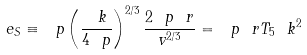<formula> <loc_0><loc_0><loc_500><loc_500>\ e _ { S } \equiv \ p \left ( \frac { \ k } { 4 \ p } \right ) ^ { 2 / 3 } \frac { 2 \ p \ r } { v ^ { 2 / 3 } } = \ p \ r T _ { 5 } \ k ^ { 2 }</formula> 